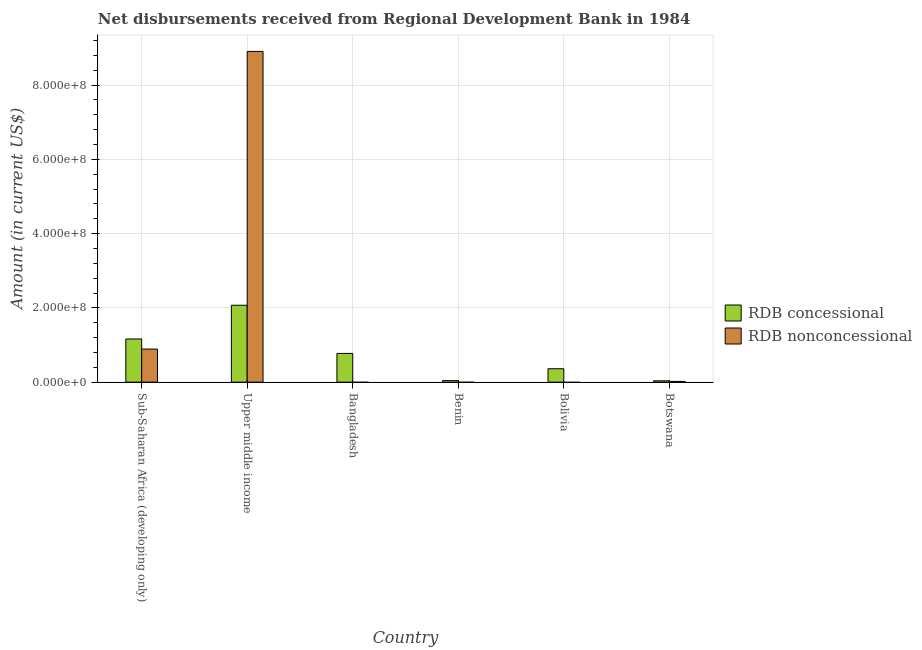How many different coloured bars are there?
Offer a terse response. 2. Are the number of bars per tick equal to the number of legend labels?
Offer a terse response. No. Are the number of bars on each tick of the X-axis equal?
Provide a short and direct response. No. How many bars are there on the 2nd tick from the left?
Keep it short and to the point. 2. How many bars are there on the 3rd tick from the right?
Keep it short and to the point. 1. What is the label of the 2nd group of bars from the left?
Ensure brevity in your answer.  Upper middle income. What is the net non concessional disbursements from rdb in Botswana?
Your answer should be very brief. 2.05e+06. Across all countries, what is the maximum net concessional disbursements from rdb?
Keep it short and to the point. 2.07e+08. Across all countries, what is the minimum net concessional disbursements from rdb?
Provide a short and direct response. 3.62e+06. In which country was the net non concessional disbursements from rdb maximum?
Your answer should be very brief. Upper middle income. What is the total net non concessional disbursements from rdb in the graph?
Offer a very short reply. 9.82e+08. What is the difference between the net concessional disbursements from rdb in Bolivia and that in Upper middle income?
Your response must be concise. -1.71e+08. What is the difference between the net concessional disbursements from rdb in Bangladesh and the net non concessional disbursements from rdb in Botswana?
Your answer should be compact. 7.53e+07. What is the average net concessional disbursements from rdb per country?
Your response must be concise. 7.41e+07. What is the difference between the net concessional disbursements from rdb and net non concessional disbursements from rdb in Upper middle income?
Your answer should be compact. -6.84e+08. In how many countries, is the net non concessional disbursements from rdb greater than 520000000 US$?
Your response must be concise. 1. What is the ratio of the net concessional disbursements from rdb in Benin to that in Bolivia?
Provide a succinct answer. 0.11. Is the net concessional disbursements from rdb in Bangladesh less than that in Benin?
Your response must be concise. No. What is the difference between the highest and the second highest net concessional disbursements from rdb?
Offer a terse response. 9.08e+07. What is the difference between the highest and the lowest net non concessional disbursements from rdb?
Your response must be concise. 8.91e+08. In how many countries, is the net non concessional disbursements from rdb greater than the average net non concessional disbursements from rdb taken over all countries?
Keep it short and to the point. 1. How many bars are there?
Keep it short and to the point. 9. Are all the bars in the graph horizontal?
Give a very brief answer. No. Are the values on the major ticks of Y-axis written in scientific E-notation?
Provide a succinct answer. Yes. What is the title of the graph?
Offer a terse response. Net disbursements received from Regional Development Bank in 1984. What is the label or title of the X-axis?
Provide a short and direct response. Country. What is the Amount (in current US$) in RDB concessional in Sub-Saharan Africa (developing only)?
Your answer should be compact. 1.16e+08. What is the Amount (in current US$) of RDB nonconcessional in Sub-Saharan Africa (developing only)?
Offer a terse response. 8.91e+07. What is the Amount (in current US$) of RDB concessional in Upper middle income?
Your answer should be very brief. 2.07e+08. What is the Amount (in current US$) in RDB nonconcessional in Upper middle income?
Make the answer very short. 8.91e+08. What is the Amount (in current US$) in RDB concessional in Bangladesh?
Offer a terse response. 7.73e+07. What is the Amount (in current US$) in RDB concessional in Benin?
Provide a short and direct response. 4.06e+06. What is the Amount (in current US$) in RDB concessional in Bolivia?
Keep it short and to the point. 3.61e+07. What is the Amount (in current US$) in RDB nonconcessional in Bolivia?
Offer a very short reply. 0. What is the Amount (in current US$) in RDB concessional in Botswana?
Your response must be concise. 3.62e+06. What is the Amount (in current US$) of RDB nonconcessional in Botswana?
Offer a terse response. 2.05e+06. Across all countries, what is the maximum Amount (in current US$) of RDB concessional?
Make the answer very short. 2.07e+08. Across all countries, what is the maximum Amount (in current US$) in RDB nonconcessional?
Keep it short and to the point. 8.91e+08. Across all countries, what is the minimum Amount (in current US$) of RDB concessional?
Keep it short and to the point. 3.62e+06. Across all countries, what is the minimum Amount (in current US$) in RDB nonconcessional?
Your response must be concise. 0. What is the total Amount (in current US$) in RDB concessional in the graph?
Provide a short and direct response. 4.45e+08. What is the total Amount (in current US$) in RDB nonconcessional in the graph?
Provide a succinct answer. 9.82e+08. What is the difference between the Amount (in current US$) in RDB concessional in Sub-Saharan Africa (developing only) and that in Upper middle income?
Keep it short and to the point. -9.08e+07. What is the difference between the Amount (in current US$) of RDB nonconcessional in Sub-Saharan Africa (developing only) and that in Upper middle income?
Provide a succinct answer. -8.02e+08. What is the difference between the Amount (in current US$) in RDB concessional in Sub-Saharan Africa (developing only) and that in Bangladesh?
Your response must be concise. 3.89e+07. What is the difference between the Amount (in current US$) in RDB concessional in Sub-Saharan Africa (developing only) and that in Benin?
Offer a terse response. 1.12e+08. What is the difference between the Amount (in current US$) of RDB concessional in Sub-Saharan Africa (developing only) and that in Bolivia?
Offer a very short reply. 8.02e+07. What is the difference between the Amount (in current US$) in RDB concessional in Sub-Saharan Africa (developing only) and that in Botswana?
Your answer should be compact. 1.13e+08. What is the difference between the Amount (in current US$) of RDB nonconcessional in Sub-Saharan Africa (developing only) and that in Botswana?
Make the answer very short. 8.70e+07. What is the difference between the Amount (in current US$) of RDB concessional in Upper middle income and that in Bangladesh?
Ensure brevity in your answer.  1.30e+08. What is the difference between the Amount (in current US$) of RDB concessional in Upper middle income and that in Benin?
Make the answer very short. 2.03e+08. What is the difference between the Amount (in current US$) in RDB concessional in Upper middle income and that in Bolivia?
Your response must be concise. 1.71e+08. What is the difference between the Amount (in current US$) in RDB concessional in Upper middle income and that in Botswana?
Offer a very short reply. 2.03e+08. What is the difference between the Amount (in current US$) in RDB nonconcessional in Upper middle income and that in Botswana?
Your answer should be very brief. 8.89e+08. What is the difference between the Amount (in current US$) of RDB concessional in Bangladesh and that in Benin?
Ensure brevity in your answer.  7.33e+07. What is the difference between the Amount (in current US$) in RDB concessional in Bangladesh and that in Bolivia?
Provide a short and direct response. 4.12e+07. What is the difference between the Amount (in current US$) in RDB concessional in Bangladesh and that in Botswana?
Your answer should be very brief. 7.37e+07. What is the difference between the Amount (in current US$) of RDB concessional in Benin and that in Bolivia?
Ensure brevity in your answer.  -3.20e+07. What is the difference between the Amount (in current US$) of RDB concessional in Benin and that in Botswana?
Offer a terse response. 4.40e+05. What is the difference between the Amount (in current US$) of RDB concessional in Bolivia and that in Botswana?
Keep it short and to the point. 3.25e+07. What is the difference between the Amount (in current US$) in RDB concessional in Sub-Saharan Africa (developing only) and the Amount (in current US$) in RDB nonconcessional in Upper middle income?
Provide a short and direct response. -7.75e+08. What is the difference between the Amount (in current US$) in RDB concessional in Sub-Saharan Africa (developing only) and the Amount (in current US$) in RDB nonconcessional in Botswana?
Give a very brief answer. 1.14e+08. What is the difference between the Amount (in current US$) of RDB concessional in Upper middle income and the Amount (in current US$) of RDB nonconcessional in Botswana?
Keep it short and to the point. 2.05e+08. What is the difference between the Amount (in current US$) of RDB concessional in Bangladesh and the Amount (in current US$) of RDB nonconcessional in Botswana?
Offer a terse response. 7.53e+07. What is the difference between the Amount (in current US$) of RDB concessional in Benin and the Amount (in current US$) of RDB nonconcessional in Botswana?
Provide a short and direct response. 2.01e+06. What is the difference between the Amount (in current US$) of RDB concessional in Bolivia and the Amount (in current US$) of RDB nonconcessional in Botswana?
Give a very brief answer. 3.41e+07. What is the average Amount (in current US$) of RDB concessional per country?
Provide a succinct answer. 7.41e+07. What is the average Amount (in current US$) of RDB nonconcessional per country?
Your response must be concise. 1.64e+08. What is the difference between the Amount (in current US$) of RDB concessional and Amount (in current US$) of RDB nonconcessional in Sub-Saharan Africa (developing only)?
Give a very brief answer. 2.72e+07. What is the difference between the Amount (in current US$) of RDB concessional and Amount (in current US$) of RDB nonconcessional in Upper middle income?
Keep it short and to the point. -6.84e+08. What is the difference between the Amount (in current US$) in RDB concessional and Amount (in current US$) in RDB nonconcessional in Botswana?
Keep it short and to the point. 1.57e+06. What is the ratio of the Amount (in current US$) in RDB concessional in Sub-Saharan Africa (developing only) to that in Upper middle income?
Make the answer very short. 0.56. What is the ratio of the Amount (in current US$) of RDB concessional in Sub-Saharan Africa (developing only) to that in Bangladesh?
Provide a short and direct response. 1.5. What is the ratio of the Amount (in current US$) of RDB concessional in Sub-Saharan Africa (developing only) to that in Benin?
Your answer should be compact. 28.62. What is the ratio of the Amount (in current US$) of RDB concessional in Sub-Saharan Africa (developing only) to that in Bolivia?
Ensure brevity in your answer.  3.22. What is the ratio of the Amount (in current US$) of RDB concessional in Sub-Saharan Africa (developing only) to that in Botswana?
Provide a short and direct response. 32.09. What is the ratio of the Amount (in current US$) of RDB nonconcessional in Sub-Saharan Africa (developing only) to that in Botswana?
Your answer should be very brief. 43.39. What is the ratio of the Amount (in current US$) of RDB concessional in Upper middle income to that in Bangladesh?
Make the answer very short. 2.68. What is the ratio of the Amount (in current US$) in RDB concessional in Upper middle income to that in Benin?
Offer a terse response. 50.97. What is the ratio of the Amount (in current US$) of RDB concessional in Upper middle income to that in Bolivia?
Make the answer very short. 5.74. What is the ratio of the Amount (in current US$) in RDB concessional in Upper middle income to that in Botswana?
Make the answer very short. 57.15. What is the ratio of the Amount (in current US$) of RDB nonconcessional in Upper middle income to that in Botswana?
Your response must be concise. 433.91. What is the ratio of the Amount (in current US$) in RDB concessional in Bangladesh to that in Benin?
Give a very brief answer. 19.03. What is the ratio of the Amount (in current US$) of RDB concessional in Bangladesh to that in Bolivia?
Offer a very short reply. 2.14. What is the ratio of the Amount (in current US$) of RDB concessional in Bangladesh to that in Botswana?
Give a very brief answer. 21.34. What is the ratio of the Amount (in current US$) in RDB concessional in Benin to that in Bolivia?
Your answer should be very brief. 0.11. What is the ratio of the Amount (in current US$) of RDB concessional in Benin to that in Botswana?
Your answer should be compact. 1.12. What is the ratio of the Amount (in current US$) of RDB concessional in Bolivia to that in Botswana?
Ensure brevity in your answer.  9.96. What is the difference between the highest and the second highest Amount (in current US$) of RDB concessional?
Provide a succinct answer. 9.08e+07. What is the difference between the highest and the second highest Amount (in current US$) of RDB nonconcessional?
Your answer should be very brief. 8.02e+08. What is the difference between the highest and the lowest Amount (in current US$) in RDB concessional?
Provide a short and direct response. 2.03e+08. What is the difference between the highest and the lowest Amount (in current US$) in RDB nonconcessional?
Your answer should be very brief. 8.91e+08. 